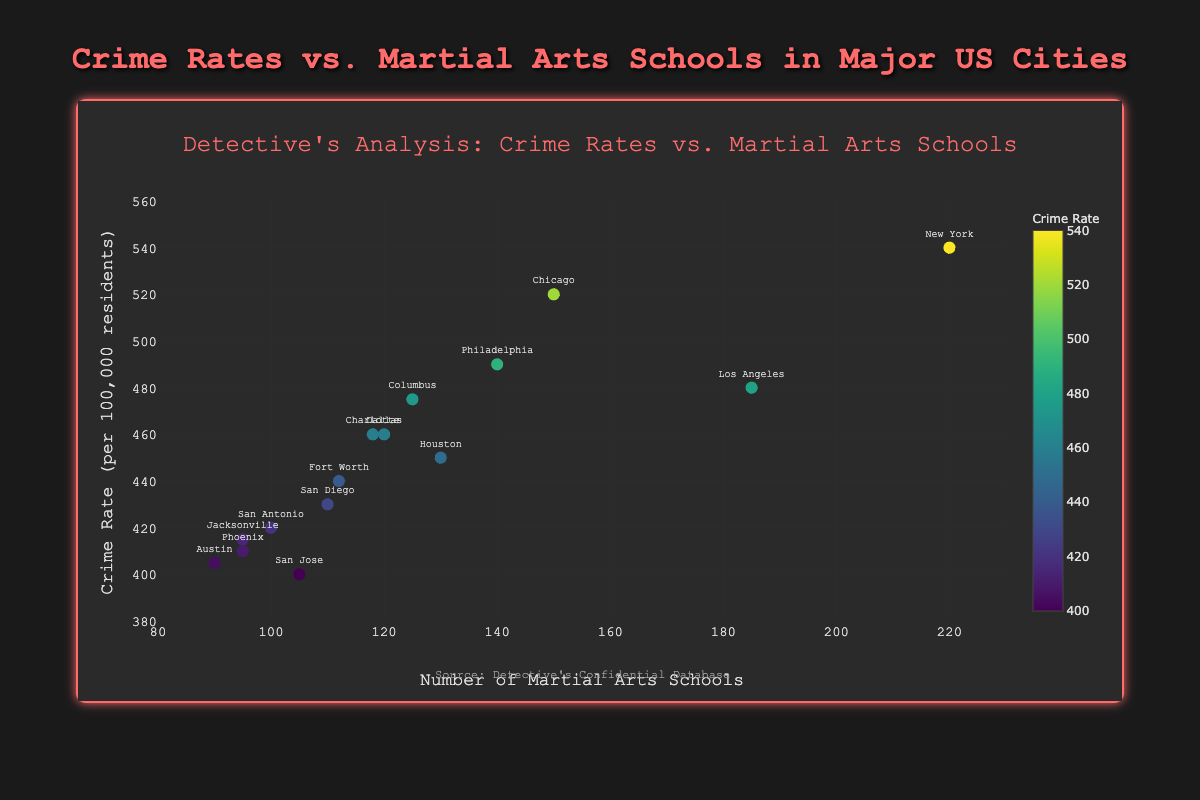What is the crime rate in New York? Locate the data point for New York on the scatter plot. The Y-axis value corresponding to New York represents the crime rate.
Answer: 540 How many martial arts schools are in Los Angeles? Find the point labeled Los Angeles and refer to its corresponding X-axis value.
Answer: 185 Which city has more martial arts schools, Phoenix or Austin? Compare the X-axis values for Phoenix and Austin.
Answer: Phoenix What is the average number of martial arts schools in the three cities with the lowest crime rates? Identify the three cities with the lowest Y-axis values (San Jose, Austin, Phoenix), sum their martial arts schools (105 + 90 + 95 = 290), and divide by 3.
Answer: 96.67 Does any city have exactly 500 crime rate? Check all Y-axis values for a point that equals 500.
Answer: No What is the color range of the markers in this plot? Markers' colors range from the lowest to highest crime rates, interpreted by the colorbar beside the plot.
Answer: Varies from light green to dark blue as per Viridis colorscale Identify the city with the highest crime rate and the highest number of martial arts schools. Look for the point with the maximum crime rate (Y-axis max value) and highest martial arts schools (X-axis max value), which is New York.
Answer: New York What are the units of the Y-axis? The Y-axis title specifies the units as "Crime Rate (per 100,000 residents)".
Answer: per 100,000 residents Compare the crime rate between San Diego and Philadelphia. Which city has a higher rate? Locate San Diego and Philadelphia data points and compare their Y-axis values.
Answer: Philadelphia 